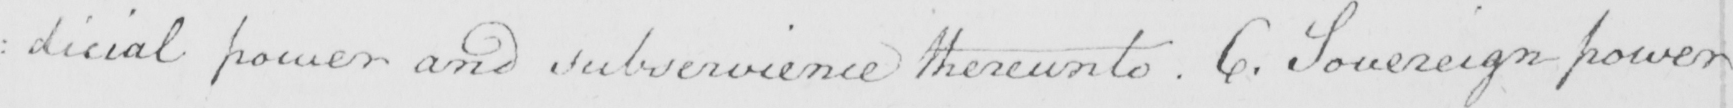Please transcribe the handwritten text in this image. : dicial power and subservience thereunto . 6 . Sovereign power 